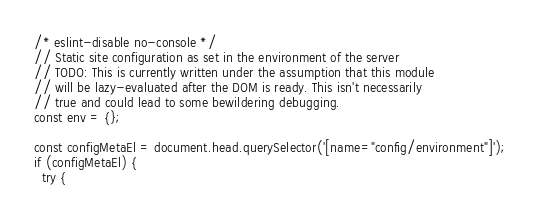<code> <loc_0><loc_0><loc_500><loc_500><_JavaScript_>/* eslint-disable no-console */
// Static site configuration as set in the environment of the server
// TODO: This is currently written under the assumption that this module
// will be lazy-evaluated after the DOM is ready. This isn't necessarily
// true and could lead to some bewildering debugging.
const env = {};

const configMetaEl = document.head.querySelector('[name="config/environment"]');
if (configMetaEl) {
  try {</code> 